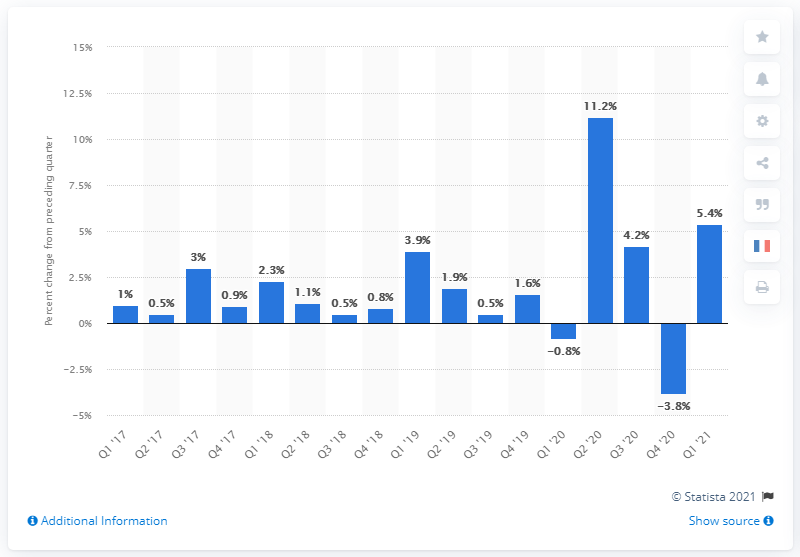Specify some key components in this picture. According to the first quarter of 2021, the nonfarm business sector labor productivity increased by 5.4%. 